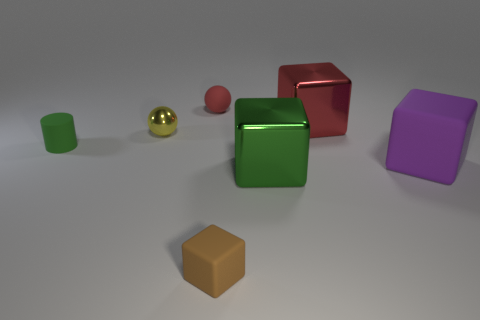Add 1 large green metallic cubes. How many objects exist? 8 Subtract all cylinders. How many objects are left? 6 Add 5 tiny purple rubber blocks. How many tiny purple rubber blocks exist? 5 Subtract 0 brown cylinders. How many objects are left? 7 Subtract all balls. Subtract all big purple shiny blocks. How many objects are left? 5 Add 7 tiny green cylinders. How many tiny green cylinders are left? 8 